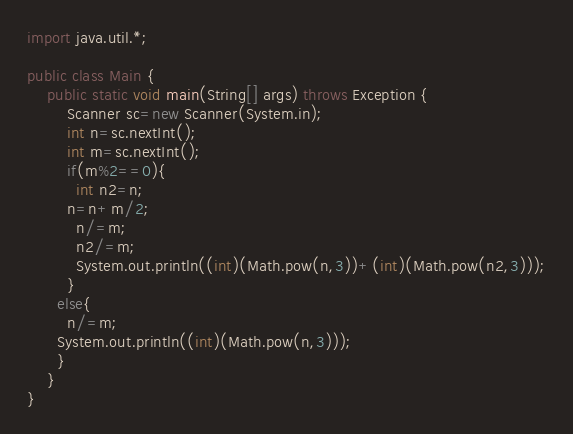<code> <loc_0><loc_0><loc_500><loc_500><_Java_>import java.util.*;

public class Main {
    public static void main(String[] args) throws Exception {
        Scanner sc=new Scanner(System.in);
        int n=sc.nextInt();
        int m=sc.nextInt();
        if(m%2==0){
          int n2=n;
        n=n+m/2;
          n/=m;
          n2/=m;
          System.out.println((int)(Math.pow(n,3))+(int)(Math.pow(n2,3)));
        }
      else{
        n/=m;
      System.out.println((int)(Math.pow(n,3)));
      }
    }
}
</code> 